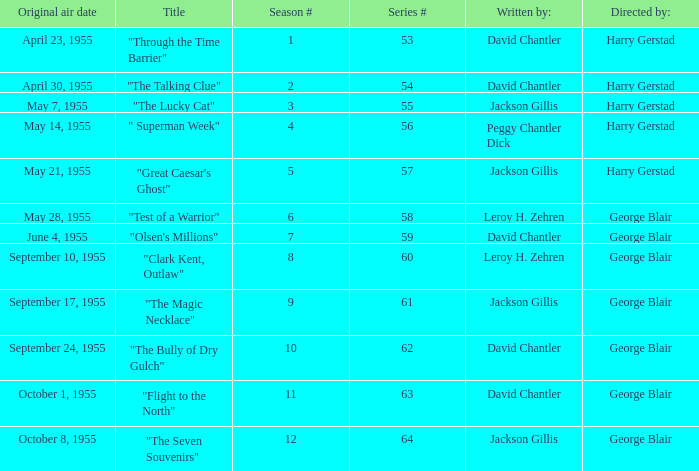What is the lowest number of series? 53.0. 